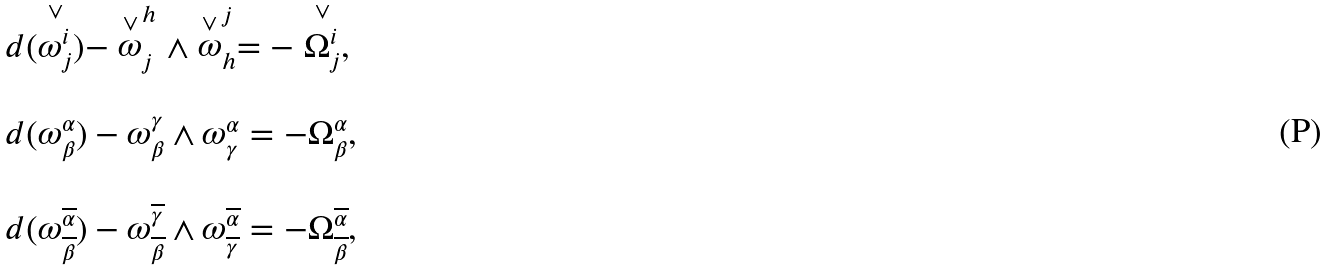<formula> <loc_0><loc_0><loc_500><loc_500>\begin{array} { l } d ( \stackrel { \vee } { \omega _ { j } ^ { i } } ) - \stackrel { \vee } { \omega } _ { j } ^ { h } \wedge \stackrel { \vee } { \omega } _ { h } ^ { j } = - \stackrel { \vee } { \Omega _ { j } ^ { i } } , \\ \\ d ( \omega _ { \beta } ^ { \alpha } ) - \omega _ { \beta } ^ { \gamma } \wedge \omega _ { \gamma } ^ { \alpha } = - \Omega _ { \beta } ^ { \alpha } , \\ \\ d ( \omega _ { \overline { \beta } } ^ { \overline { \alpha } } ) - \omega _ { \overline { \beta } } ^ { \overline { \gamma } } \wedge \omega _ { \overline { \gamma } } ^ { \overline { \alpha } } = - \Omega _ { \overline { \beta } } ^ { \overline { \alpha } } , \end{array}</formula> 